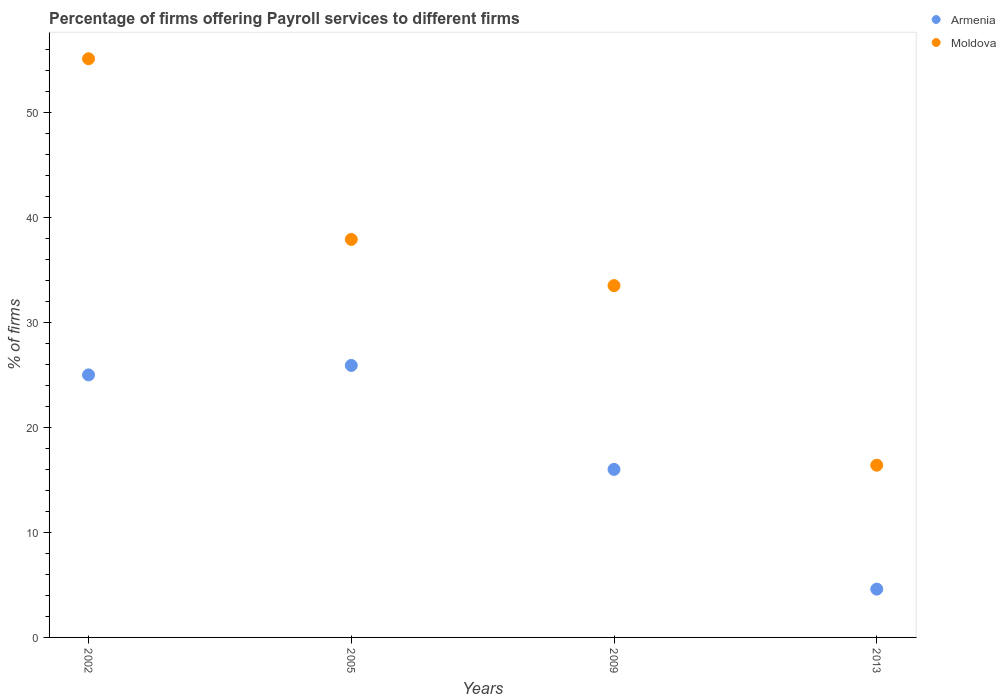How many different coloured dotlines are there?
Your response must be concise. 2. Is the number of dotlines equal to the number of legend labels?
Your answer should be compact. Yes. What is the percentage of firms offering payroll services in Moldova in 2005?
Provide a succinct answer. 37.9. Across all years, what is the maximum percentage of firms offering payroll services in Moldova?
Make the answer very short. 55.1. In which year was the percentage of firms offering payroll services in Armenia minimum?
Your answer should be compact. 2013. What is the total percentage of firms offering payroll services in Armenia in the graph?
Keep it short and to the point. 71.5. What is the difference between the percentage of firms offering payroll services in Moldova in 2002 and that in 2013?
Give a very brief answer. 38.7. What is the difference between the percentage of firms offering payroll services in Moldova in 2002 and the percentage of firms offering payroll services in Armenia in 2013?
Provide a short and direct response. 50.5. What is the average percentage of firms offering payroll services in Armenia per year?
Offer a terse response. 17.88. In the year 2005, what is the difference between the percentage of firms offering payroll services in Armenia and percentage of firms offering payroll services in Moldova?
Give a very brief answer. -12. In how many years, is the percentage of firms offering payroll services in Armenia greater than 28 %?
Offer a terse response. 0. What is the ratio of the percentage of firms offering payroll services in Moldova in 2002 to that in 2009?
Your answer should be compact. 1.64. What is the difference between the highest and the second highest percentage of firms offering payroll services in Moldova?
Provide a short and direct response. 17.2. What is the difference between the highest and the lowest percentage of firms offering payroll services in Moldova?
Keep it short and to the point. 38.7. In how many years, is the percentage of firms offering payroll services in Moldova greater than the average percentage of firms offering payroll services in Moldova taken over all years?
Make the answer very short. 2. Does the percentage of firms offering payroll services in Moldova monotonically increase over the years?
Provide a short and direct response. No. Is the percentage of firms offering payroll services in Armenia strictly greater than the percentage of firms offering payroll services in Moldova over the years?
Provide a succinct answer. No. What is the difference between two consecutive major ticks on the Y-axis?
Make the answer very short. 10. Are the values on the major ticks of Y-axis written in scientific E-notation?
Your answer should be very brief. No. How many legend labels are there?
Your response must be concise. 2. How are the legend labels stacked?
Offer a terse response. Vertical. What is the title of the graph?
Offer a terse response. Percentage of firms offering Payroll services to different firms. What is the label or title of the Y-axis?
Make the answer very short. % of firms. What is the % of firms of Armenia in 2002?
Provide a short and direct response. 25. What is the % of firms of Moldova in 2002?
Provide a short and direct response. 55.1. What is the % of firms in Armenia in 2005?
Provide a succinct answer. 25.9. What is the % of firms of Moldova in 2005?
Ensure brevity in your answer.  37.9. What is the % of firms in Moldova in 2009?
Your answer should be very brief. 33.5. Across all years, what is the maximum % of firms of Armenia?
Your answer should be very brief. 25.9. Across all years, what is the maximum % of firms in Moldova?
Make the answer very short. 55.1. Across all years, what is the minimum % of firms in Armenia?
Your answer should be compact. 4.6. What is the total % of firms of Armenia in the graph?
Your answer should be compact. 71.5. What is the total % of firms in Moldova in the graph?
Provide a succinct answer. 142.9. What is the difference between the % of firms in Armenia in 2002 and that in 2005?
Your response must be concise. -0.9. What is the difference between the % of firms in Moldova in 2002 and that in 2009?
Your response must be concise. 21.6. What is the difference between the % of firms in Armenia in 2002 and that in 2013?
Make the answer very short. 20.4. What is the difference between the % of firms of Moldova in 2002 and that in 2013?
Offer a terse response. 38.7. What is the difference between the % of firms of Moldova in 2005 and that in 2009?
Ensure brevity in your answer.  4.4. What is the difference between the % of firms in Armenia in 2005 and that in 2013?
Offer a terse response. 21.3. What is the difference between the % of firms in Armenia in 2002 and the % of firms in Moldova in 2005?
Your response must be concise. -12.9. What is the difference between the % of firms in Armenia in 2002 and the % of firms in Moldova in 2013?
Keep it short and to the point. 8.6. What is the difference between the % of firms of Armenia in 2005 and the % of firms of Moldova in 2009?
Provide a succinct answer. -7.6. What is the difference between the % of firms in Armenia in 2005 and the % of firms in Moldova in 2013?
Offer a terse response. 9.5. What is the average % of firms of Armenia per year?
Your response must be concise. 17.88. What is the average % of firms in Moldova per year?
Your answer should be compact. 35.73. In the year 2002, what is the difference between the % of firms of Armenia and % of firms of Moldova?
Provide a succinct answer. -30.1. In the year 2009, what is the difference between the % of firms in Armenia and % of firms in Moldova?
Give a very brief answer. -17.5. What is the ratio of the % of firms of Armenia in 2002 to that in 2005?
Your answer should be very brief. 0.97. What is the ratio of the % of firms of Moldova in 2002 to that in 2005?
Keep it short and to the point. 1.45. What is the ratio of the % of firms in Armenia in 2002 to that in 2009?
Give a very brief answer. 1.56. What is the ratio of the % of firms in Moldova in 2002 to that in 2009?
Offer a very short reply. 1.64. What is the ratio of the % of firms of Armenia in 2002 to that in 2013?
Provide a short and direct response. 5.43. What is the ratio of the % of firms of Moldova in 2002 to that in 2013?
Offer a terse response. 3.36. What is the ratio of the % of firms of Armenia in 2005 to that in 2009?
Your response must be concise. 1.62. What is the ratio of the % of firms in Moldova in 2005 to that in 2009?
Your response must be concise. 1.13. What is the ratio of the % of firms in Armenia in 2005 to that in 2013?
Offer a very short reply. 5.63. What is the ratio of the % of firms in Moldova in 2005 to that in 2013?
Your answer should be compact. 2.31. What is the ratio of the % of firms in Armenia in 2009 to that in 2013?
Provide a short and direct response. 3.48. What is the ratio of the % of firms of Moldova in 2009 to that in 2013?
Offer a very short reply. 2.04. What is the difference between the highest and the lowest % of firms of Armenia?
Ensure brevity in your answer.  21.3. What is the difference between the highest and the lowest % of firms of Moldova?
Offer a terse response. 38.7. 